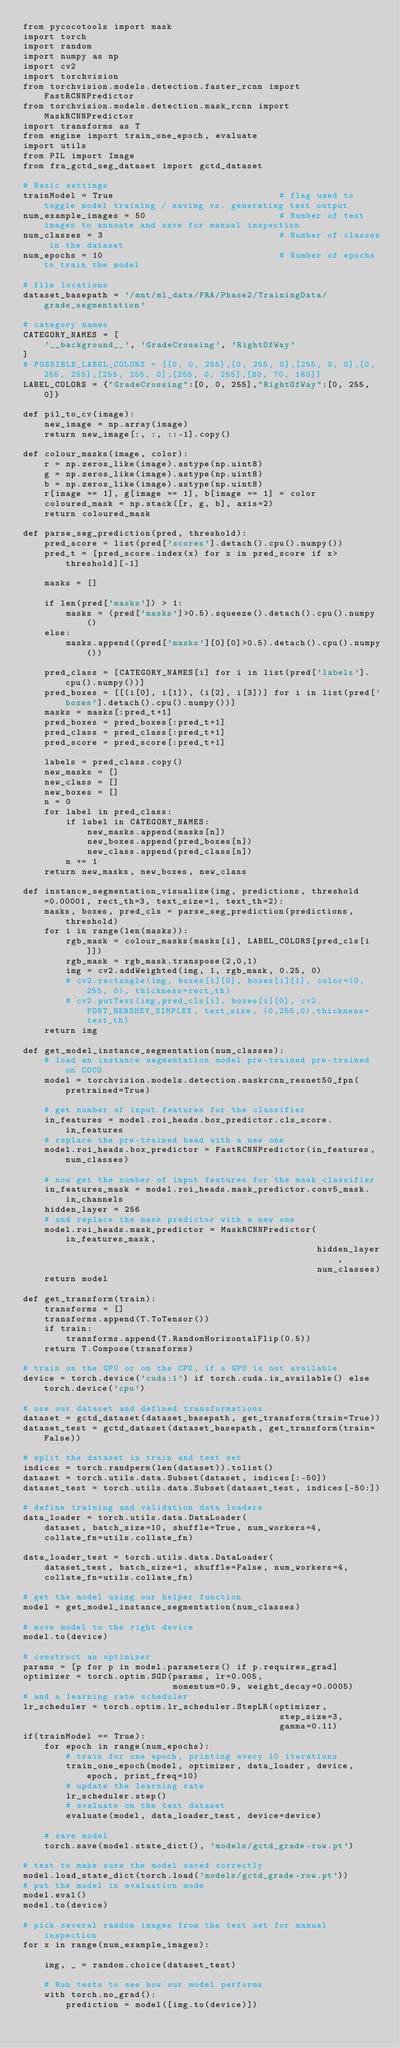<code> <loc_0><loc_0><loc_500><loc_500><_Python_>from pycocotools import mask
import torch
import random
import numpy as np
import cv2
import torchvision
from torchvision.models.detection.faster_rcnn import FastRCNNPredictor
from torchvision.models.detection.mask_rcnn import MaskRCNNPredictor
import transforms as T
from engine import train_one_epoch, evaluate
import utils
from PIL import Image
from fra_gctd_seg_dataset import gctd_dataset

# Basic settings
trainModel = True                               # flag used to toggle model training / saving vs. generating test output
num_example_images = 50                         # Number of test images to annoate and save for manual inspection
num_classes = 3                                 # Number of classes in the dataset
num_epochs = 10                                 # Number of epochs to train the model

# file locations
dataset_basepath = '/mnt/ml_data/FRA/Phase2/TrainingData/grade_segmentation'

# category names
CATEGORY_NAMES = [
    '__background__', 'GradeCrossing', 'RightOfWay'
]
# POSSIBLE_LABEL_COLORS = [[0, 0, 255],[0, 255, 0],[255, 0, 0],[0, 255, 255],[255, 255, 0],[255, 0, 255],[80, 70, 180]]
LABEL_COLORS = {"GradeCrossing":[0, 0, 255],"RightOfWay":[0, 255, 0]}

def pil_to_cv(image):
    new_image = np.array(image)
    return new_image[:, :, ::-1].copy()

def colour_masks(image, color):
    r = np.zeros_like(image).astype(np.uint8)
    g = np.zeros_like(image).astype(np.uint8)
    b = np.zeros_like(image).astype(np.uint8)
    r[image == 1], g[image == 1], b[image == 1] = color
    coloured_mask = np.stack([r, g, b], axis=2)
    return coloured_mask

def parse_seg_prediction(pred, threshold):
    pred_score = list(pred['scores'].detach().cpu().numpy())
    pred_t = [pred_score.index(x) for x in pred_score if x>threshold][-1]

    masks = []

    if len(pred['masks']) > 1:
        masks = (pred['masks']>0.5).squeeze().detach().cpu().numpy()
    else:
        masks.append((pred['masks'][0][0]>0.5).detach().cpu().numpy())
    
    pred_class = [CATEGORY_NAMES[i] for i in list(pred['labels'].cpu().numpy())]
    pred_boxes = [[(i[0], i[1]), (i[2], i[3])] for i in list(pred['boxes'].detach().cpu().numpy())]
    masks = masks[:pred_t+1]
    pred_boxes = pred_boxes[:pred_t+1]
    pred_class = pred_class[:pred_t+1]
    pred_score = pred_score[:pred_t+1]

    labels = pred_class.copy()
    new_masks = []
    new_class = []
    new_boxes = []
    n = 0
    for label in pred_class:
        if label in CATEGORY_NAMES:
            new_masks.append(masks[n])
            new_boxes.append(pred_boxes[n])
            new_class.append(pred_class[n])
        n += 1
    return new_masks, new_boxes, new_class

def instance_segmentation_visualize(img, predictions, threshold=0.00001, rect_th=3, text_size=1, text_th=2):
    masks, boxes, pred_cls = parse_seg_prediction(predictions, threshold)
    for i in range(len(masks)):
        rgb_mask = colour_masks(masks[i], LABEL_COLORS[pred_cls[i]])
        rgb_mask = rgb_mask.transpose(2,0,1)
        img = cv2.addWeighted(img, 1, rgb_mask, 0.25, 0)
        # cv2.rectangle(img, boxes[i][0], boxes[i][1], color=(0, 255, 0), thickness=rect_th)
        # cv2.putText(img,pred_cls[i], boxes[i][0], cv2.FONT_HERSHEY_SIMPLEX, text_size, (0,255,0),thickness=text_th)
    return img

def get_model_instance_segmentation(num_classes):
    # load an instance segmentation model pre-trained pre-trained on COCO
    model = torchvision.models.detection.maskrcnn_resnet50_fpn(pretrained=True)

    # get number of input features for the classifier
    in_features = model.roi_heads.box_predictor.cls_score.in_features
    # replace the pre-trained head with a new one
    model.roi_heads.box_predictor = FastRCNNPredictor(in_features, num_classes)

    # now get the number of input features for the mask classifier
    in_features_mask = model.roi_heads.mask_predictor.conv5_mask.in_channels
    hidden_layer = 256
    # and replace the mask predictor with a new one
    model.roi_heads.mask_predictor = MaskRCNNPredictor(in_features_mask,
                                                       hidden_layer,
                                                       num_classes)
    return model

def get_transform(train):
    transforms = []
    transforms.append(T.ToTensor())
    if train:
        transforms.append(T.RandomHorizontalFlip(0.5))
    return T.Compose(transforms)

# train on the GPU or on the CPU, if a GPU is not available
device = torch.device('cuda:1') if torch.cuda.is_available() else torch.device('cpu')

# use our dataset and defined transformations
dataset = gctd_dataset(dataset_basepath, get_transform(train=True))
dataset_test = gctd_dataset(dataset_basepath, get_transform(train=False))

# split the dataset in train and test set
indices = torch.randperm(len(dataset)).tolist()
dataset = torch.utils.data.Subset(dataset, indices[:-50])
dataset_test = torch.utils.data.Subset(dataset_test, indices[-50:])

# define training and validation data loaders
data_loader = torch.utils.data.DataLoader(
    dataset, batch_size=10, shuffle=True, num_workers=4,
    collate_fn=utils.collate_fn)

data_loader_test = torch.utils.data.DataLoader(
    dataset_test, batch_size=1, shuffle=False, num_workers=4,
    collate_fn=utils.collate_fn)

# get the model using our helper function
model = get_model_instance_segmentation(num_classes)

# move model to the right device
model.to(device)

# construct an optimizer
params = [p for p in model.parameters() if p.requires_grad]
optimizer = torch.optim.SGD(params, lr=0.005,
                            momentum=0.9, weight_decay=0.0005)
# and a learning rate scheduler
lr_scheduler = torch.optim.lr_scheduler.StepLR(optimizer,
                                                step_size=3,
                                                gamma=0.11)
if(trainModel == True):
    for epoch in range(num_epochs):
        # train for one epoch, printing every 10 iterations
        train_one_epoch(model, optimizer, data_loader, device, epoch, print_freq=10)
        # update the learning rate
        lr_scheduler.step()
        # evaluate on the test dataset
        evaluate(model, data_loader_test, device=device)

    # save model
    torch.save(model.state_dict(), 'models/gctd_grade-row.pt')

# test to make sure the model saved correctly
model.load_state_dict(torch.load('models/gctd_grade-row.pt'))
# put the model in evaluation mode
model.eval()
model.to(device)

# pick several random images from the test set for manual inspection
for x in range(num_example_images):

    img, _ = random.choice(dataset_test)

    # Run tests to see how our model performs
    with torch.no_grad():
        prediction = model([img.to(device)])</code> 